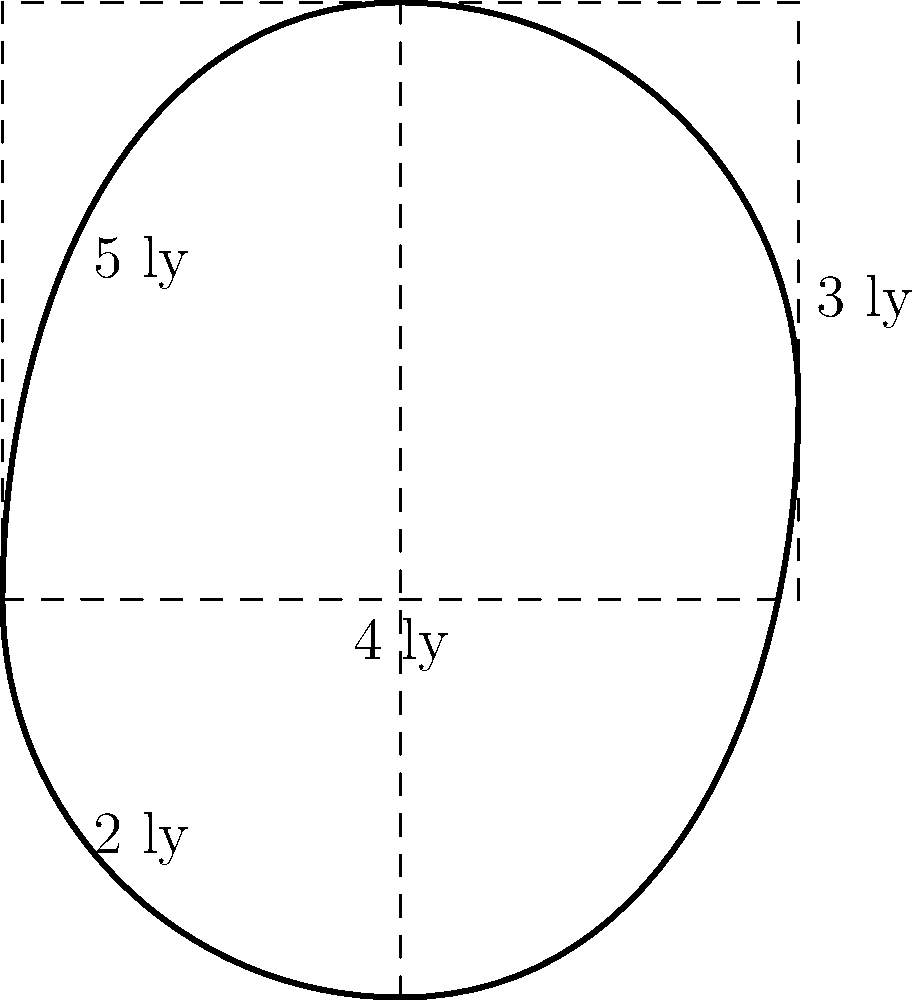As part of your dark matter research, you're analyzing an irregular galaxy shape. To estimate its area, you decide to approximate it using simple geometric shapes. The galaxy's dimensions are given in light-years (ly). Calculate the approximate area of this galaxy using a rectangle and two triangles. Round your answer to the nearest square light-year. To approximate the area of the irregular galaxy shape, we'll use a rectangle for the main body and two triangles for the top and bottom protrusions. Let's break it down step-by-step:

1) Rectangle area:
   Width = $4$ ly
   Height = $3$ ly
   Area of rectangle = $4 \times 3 = 12$ sq ly

2) Upper triangle area:
   Base = $2$ ly (half the width of the rectangle)
   Height = $2$ ly (given in the diagram)
   Area of upper triangle = $\frac{1}{2} \times 2 \times 2 = 2$ sq ly

3) Lower triangle area:
   Base = $2$ ly (half the width of the rectangle)
   Height = $2$ ly (given in the diagram)
   Area of lower triangle = $\frac{1}{2} \times 2 \times 2 = 2$ sq ly

4) Total approximate area:
   Total area = Rectangle area + Upper triangle area + Lower triangle area
               = $12 + 2 + 2 = 16$ sq ly

Therefore, the approximate area of the galaxy is 16 square light-years.
Answer: $16$ sq ly 